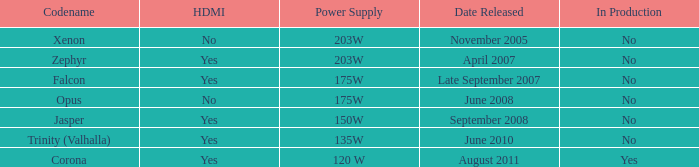Is Jasper being producted? No. Give me the full table as a dictionary. {'header': ['Codename', 'HDMI', 'Power Supply', 'Date Released', 'In Production'], 'rows': [['Xenon', 'No', '203W', 'November 2005', 'No'], ['Zephyr', 'Yes', '203W', 'April 2007', 'No'], ['Falcon', 'Yes', '175W', 'Late September 2007', 'No'], ['Opus', 'No', '175W', 'June 2008', 'No'], ['Jasper', 'Yes', '150W', 'September 2008', 'No'], ['Trinity (Valhalla)', 'Yes', '135W', 'June 2010', 'No'], ['Corona', 'Yes', '120 W', 'August 2011', 'Yes']]} 